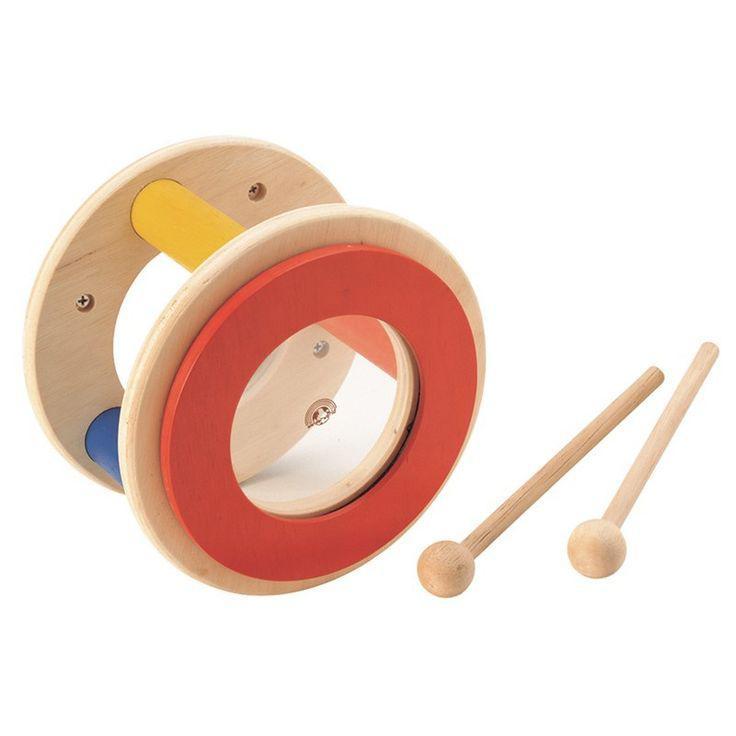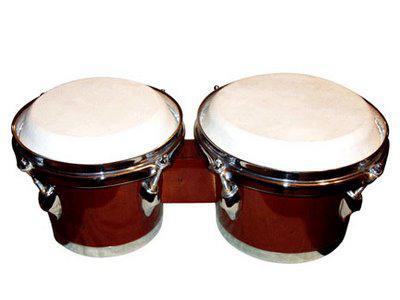The first image is the image on the left, the second image is the image on the right. Evaluate the accuracy of this statement regarding the images: "There are drum sticks in the left image.". Is it true? Answer yes or no. Yes. The first image is the image on the left, the second image is the image on the right. Considering the images on both sides, is "The right image shows connected drums with solid-colored sides and white tops, and the left image features two drumsticks and a cylinder shape." valid? Answer yes or no. Yes. 